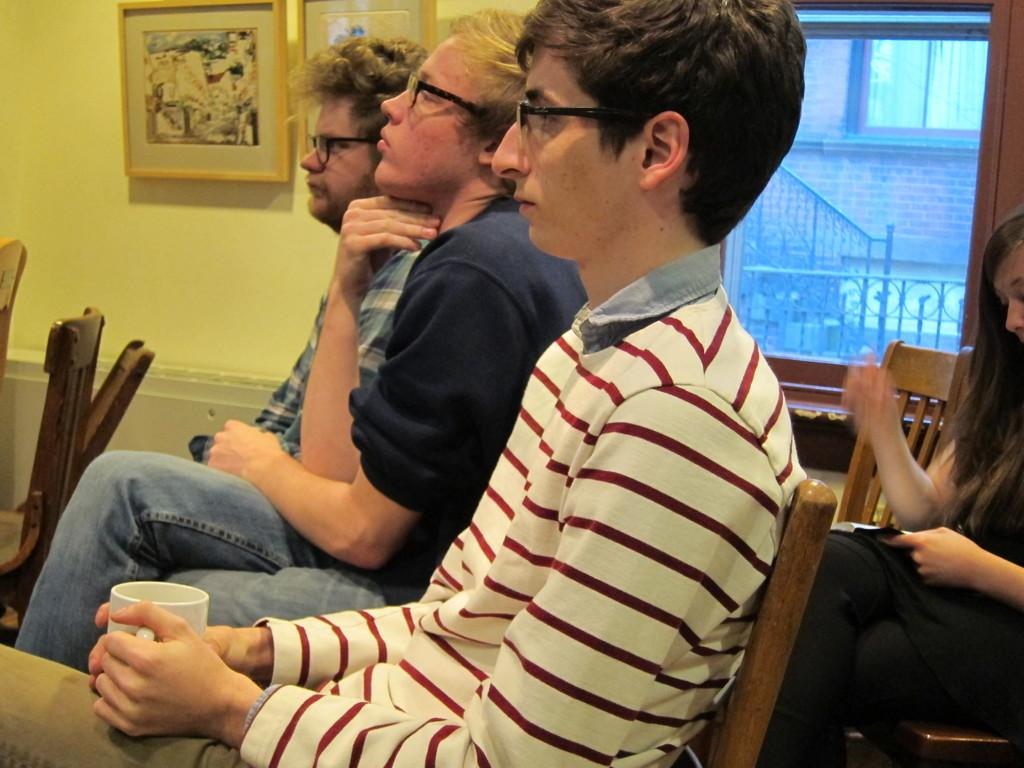What are the people in the image doing? The people in the image are sitting on chairs. What can be seen in the background of the image? There is a wall in the background of the image. What feature of the wall is mentioned in the facts? There is a window in the wall. What decorative elements are present on the wall? There are frames on the wall. How many trains can be seen passing by the window in the image? There are no trains visible in the image; it only shows people sitting on chairs, a wall, a window, and frames on the wall. 